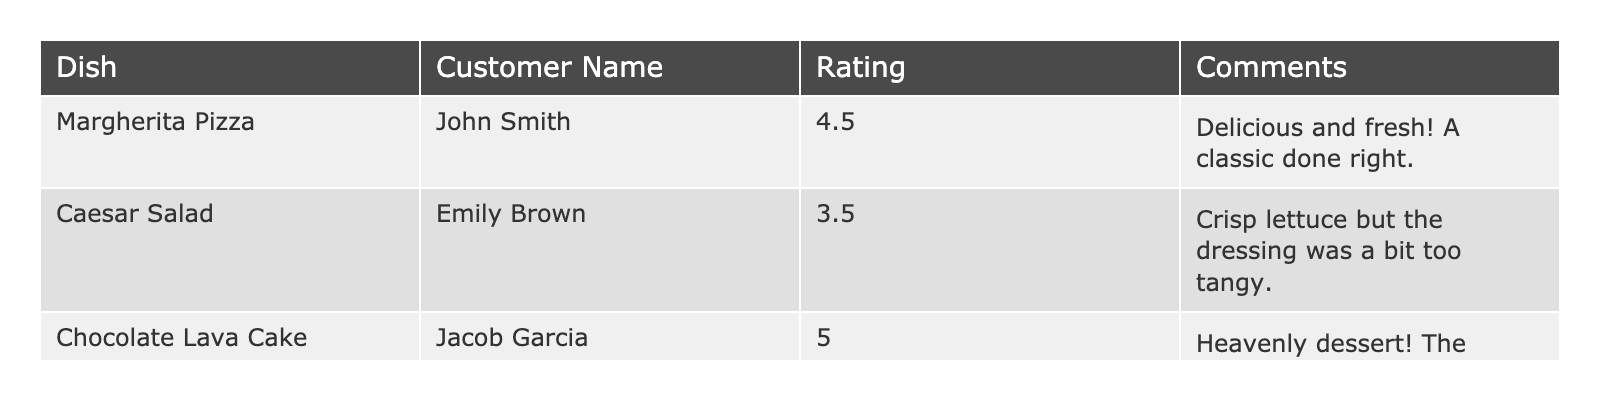What was the rating for the Chocolate Lava Cake? The table indicates that Jacob Garcia rated the Chocolate Lava Cake with a score of 5.0.
Answer: 5.0 Which dish received the lowest rating? By reviewing the ratings in the table, the Caesar Salad has the lowest score of 3.5 compared to others.
Answer: Caesar Salad What is the average rating of all dishes presented in the table? Adding the ratings (4.5, 3.5, and 5.0) gives 13.0; dividing by the number of dishes (3) results in an average rating of 4.33.
Answer: 4.33 Did any dish receive a rating of 4 or higher? At least one dish (Margherita Pizza and Chocolate Lava Cake) has a rating of 4 or higher, confirming that the statement is true.
Answer: Yes How many dishes received a rating above 4? The table shows two dishes, the Margherita Pizza (4.5) and the Chocolate Lava Cake (5.0), received ratings above 4.
Answer: 2 Is the statement "Emily Brown enjoyed the Margherita Pizza" true based on her rating? Emily Brown did not rate the Margherita Pizza; she rated the Caesar Salad, hence the statement is false.
Answer: No What is the total rating score of all dishes combined? Adding all the ratings together (4.5 + 3.5 + 5.0) results in a total score of 13.0.
Answer: 13.0 How many customers left feedback on desserts? Only one customer, Jacob Garcia, provided feedback on a dessert, the Chocolate Lava Cake.
Answer: 1 What is the difference in ratings between the highest and lowest rated dishes? The highest rating is from the Chocolate Lava Cake (5.0) and the lowest from the Caesar Salad (3.5), so the difference is 5.0 - 3.5 = 1.5.
Answer: 1.5 